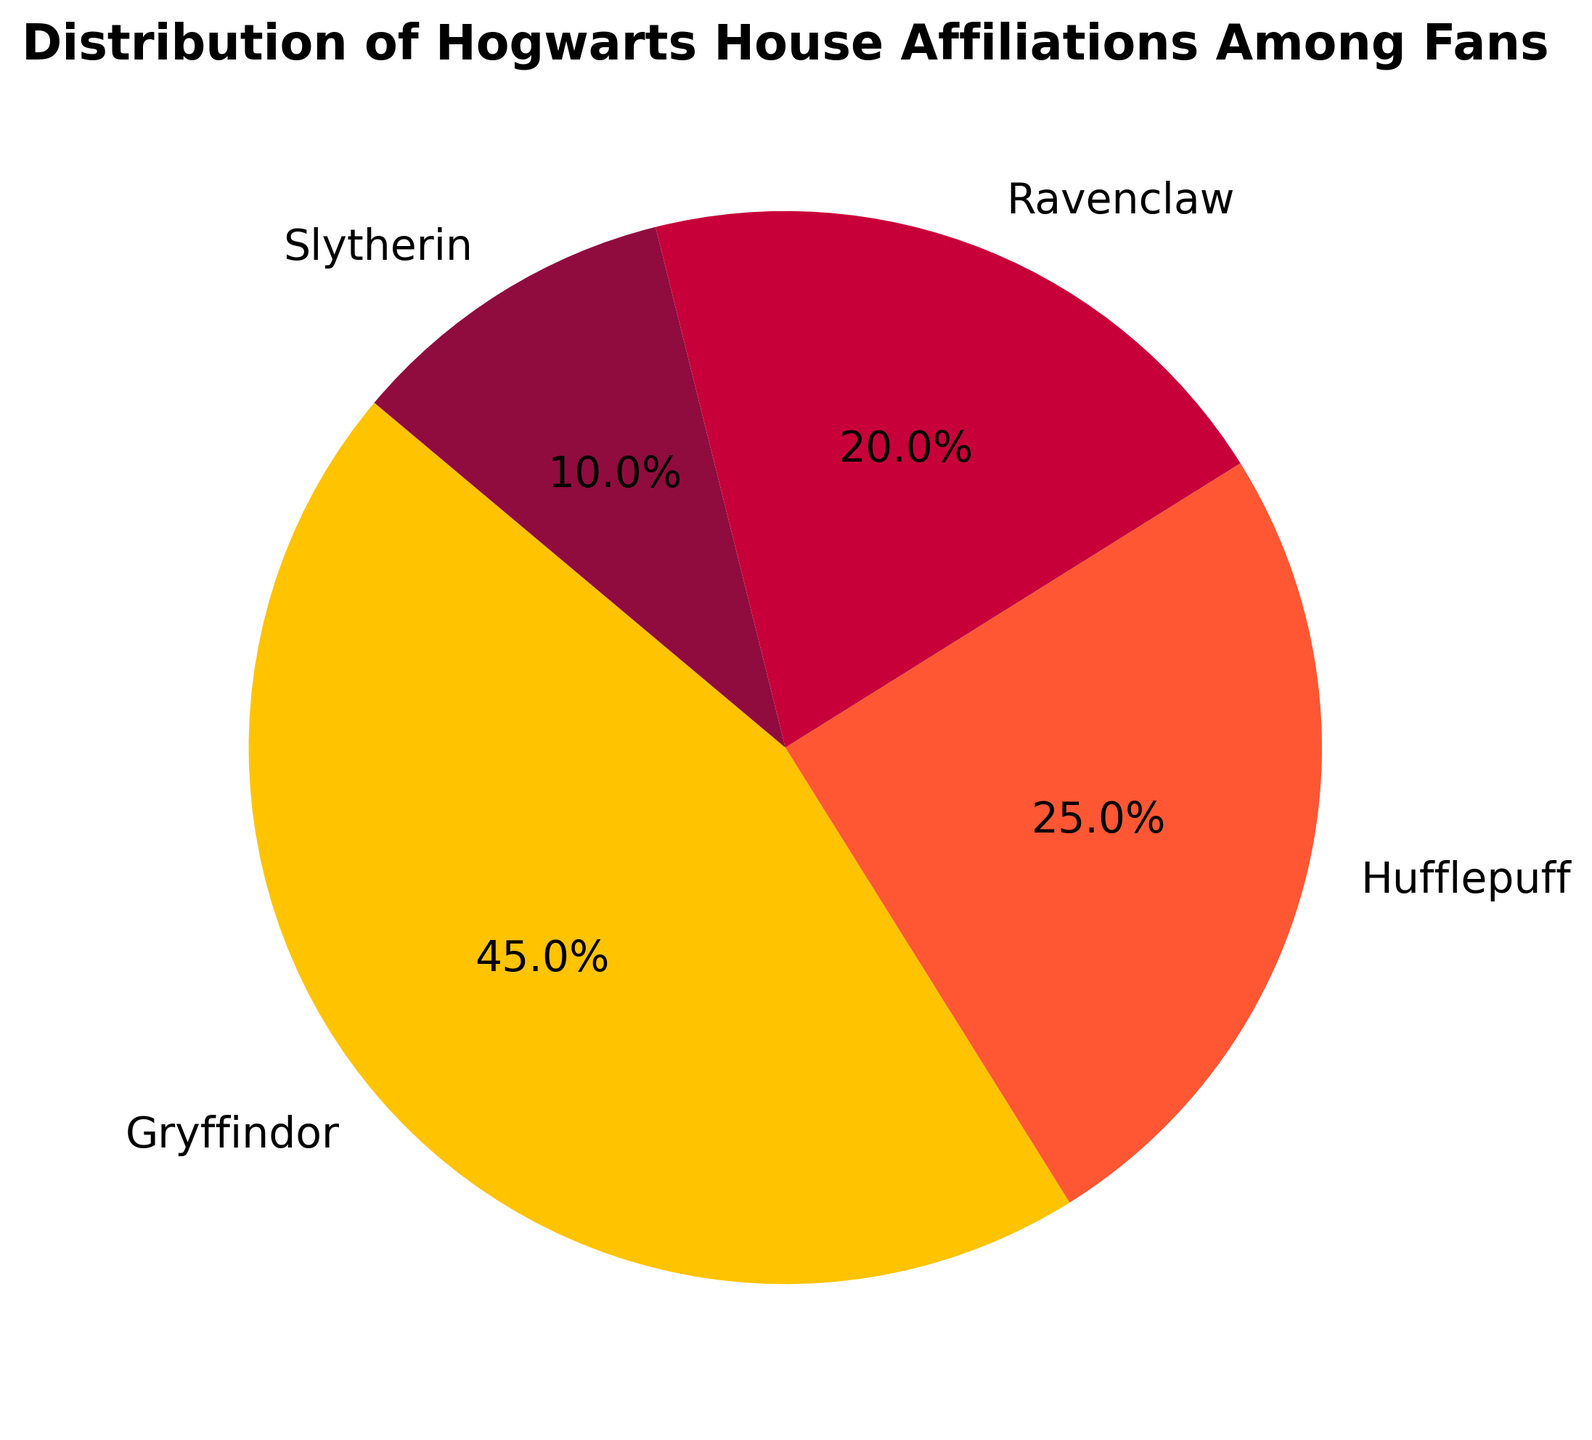What is the most popular Hogwarts house among the fans? By looking at the percentages, the Gryffindor house has the highest percentage with 45%.
Answer: Gryffindor Which two houses combined have exactly half of the fans? Summing the percentages of Hufflepuff and Ravenclaw gives us 25 + 20 = 45, which is not half. Similarly, Gryffindor + Slytherin is 45 + 10 = 55, which is not half. When taking Hufflepuff and Slytherin, their sum (25 + 10) is 35, also not half. However, combining Hufflepuff and Ravenclaw gives 25 + 20 = 50, which is exactly half.
Answer: Hufflepuff and Ravenclaw Which house has the least number of fans? Observing the percentages, Slytherin has the smallest percentage at 10%.
Answer: Slytherin How much more popular is Gryffindor compared to Slytherin? Subtracting Slytherin's percentage from Gryffindor's percentage gives 45 - 10 = 35%.
Answer: 35% What is the percentage of fans that do not belong to Gryffindor? Adding the percentages of Hufflepuff, Ravenclaw, and Slytherin results in 25 + 20 + 10 = 55%.
Answer: 55% Which house has more fans, Hufflepuff or Ravenclaw? Comparing their percentages, Hufflepuff has 25% while Ravenclaw has 20%. 25% is greater than 20%.
Answer: Hufflepuff If the total number of fans is 1000, how many fans belong to Ravenclaw? Ravenclaw has 20% of the fans. Thus, 20% of 1000 is 0.2 * 1000 = 200 fans.
Answer: 200 What percentage of fans belong to Gryffindor or Hufflepuff? Summing the percentages of Gryffindor and Hufflepuff gives us 45 + 25 = 70%.
Answer: 70% How does the fanbase of Hufflepuff compare to that of Slytherin in terms of their ratio? Hufflepuff has 25% and Slytherin has 10%. The ratio of Hufflepuff to Slytherin is 25:10, which simplifies to 5:2.
Answer: 5:2 